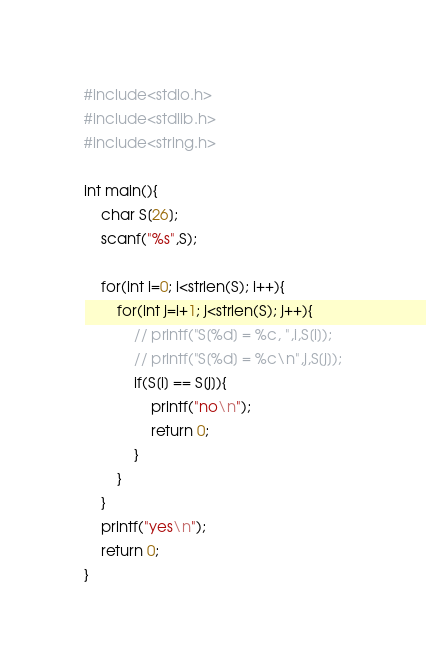Convert code to text. <code><loc_0><loc_0><loc_500><loc_500><_C_>#include<stdio.h>
#include<stdlib.h>
#include<string.h>

int main(){
	char S[26];
	scanf("%s",S);

	for(int i=0; i<strlen(S); i++){
		for(int j=i+1; j<strlen(S); j++){
			// printf("S[%d] = %c, ",i,S[i]);
			// printf("S[%d] = %c\n",j,S[j]);
			if(S[i] == S[j]){
				printf("no\n");
				return 0;
			}
		}
	}
	printf("yes\n");
	return 0;
}</code> 